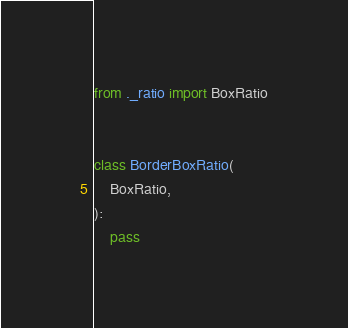<code> <loc_0><loc_0><loc_500><loc_500><_Python_>from ._ratio import BoxRatio


class BorderBoxRatio(
    BoxRatio,
):
    pass
</code> 